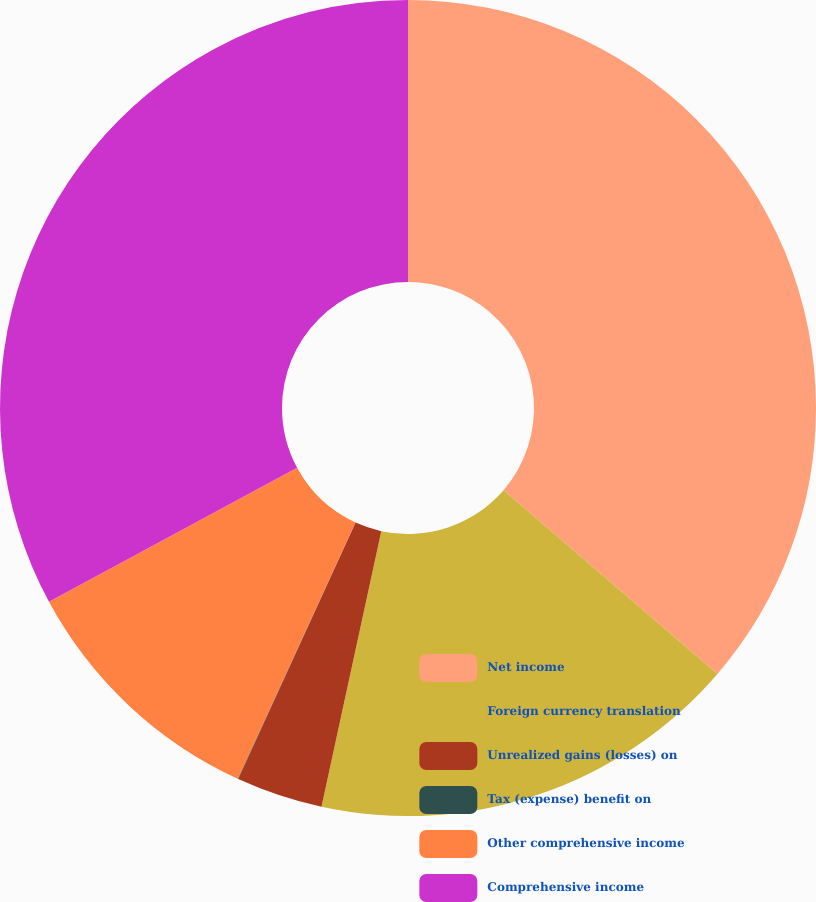Convert chart to OTSL. <chart><loc_0><loc_0><loc_500><loc_500><pie_chart><fcel>Net income<fcel>Foreign currency translation<fcel>Unrealized gains (losses) on<fcel>Tax (expense) benefit on<fcel>Other comprehensive income<fcel>Comprehensive income<nl><fcel>36.3%<fcel>17.1%<fcel>3.43%<fcel>0.02%<fcel>10.27%<fcel>32.88%<nl></chart> 